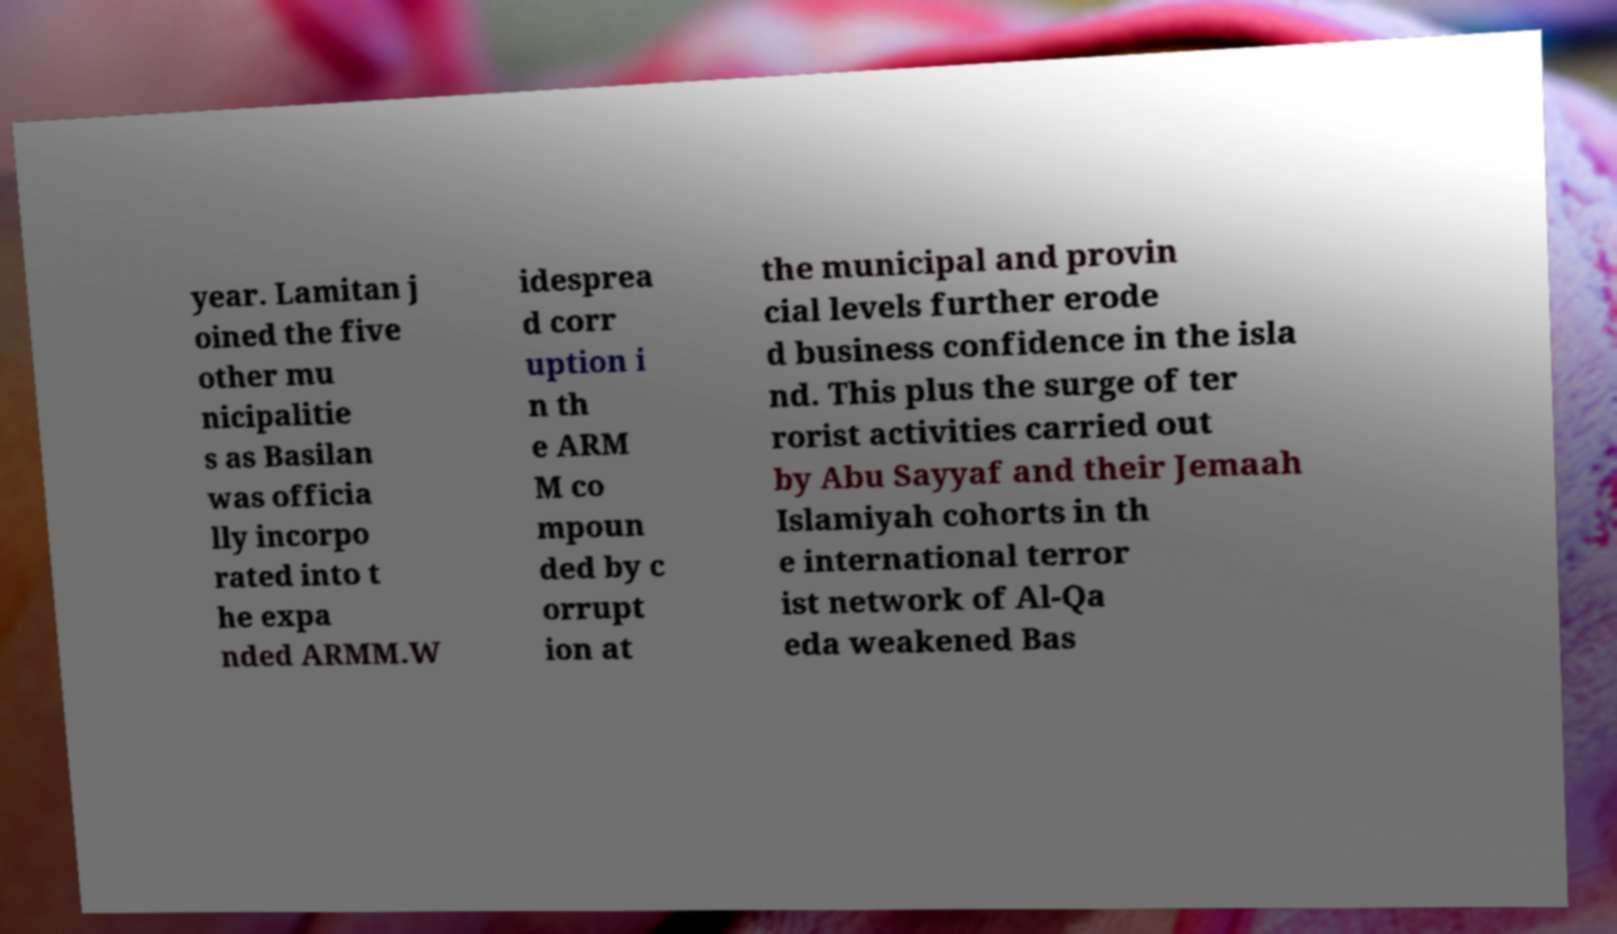Can you read and provide the text displayed in the image?This photo seems to have some interesting text. Can you extract and type it out for me? year. Lamitan j oined the five other mu nicipalitie s as Basilan was officia lly incorpo rated into t he expa nded ARMM.W idesprea d corr uption i n th e ARM M co mpoun ded by c orrupt ion at the municipal and provin cial levels further erode d business confidence in the isla nd. This plus the surge of ter rorist activities carried out by Abu Sayyaf and their Jemaah Islamiyah cohorts in th e international terror ist network of Al-Qa eda weakened Bas 